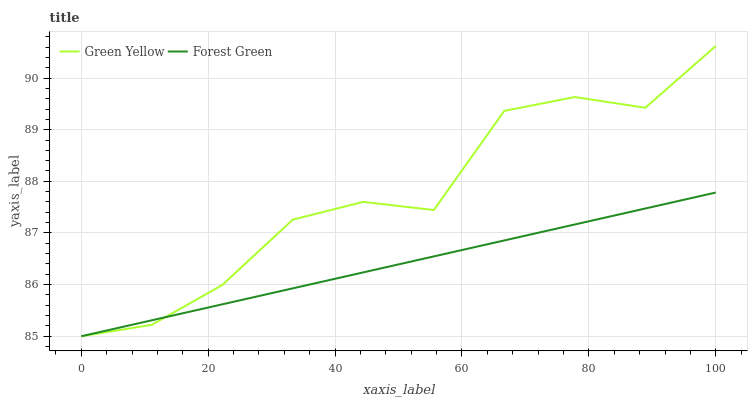Does Forest Green have the minimum area under the curve?
Answer yes or no. Yes. Does Green Yellow have the maximum area under the curve?
Answer yes or no. Yes. Does Green Yellow have the minimum area under the curve?
Answer yes or no. No. Is Forest Green the smoothest?
Answer yes or no. Yes. Is Green Yellow the roughest?
Answer yes or no. Yes. Is Green Yellow the smoothest?
Answer yes or no. No. Does Forest Green have the lowest value?
Answer yes or no. Yes. Does Green Yellow have the highest value?
Answer yes or no. Yes. Does Green Yellow intersect Forest Green?
Answer yes or no. Yes. Is Green Yellow less than Forest Green?
Answer yes or no. No. Is Green Yellow greater than Forest Green?
Answer yes or no. No. 